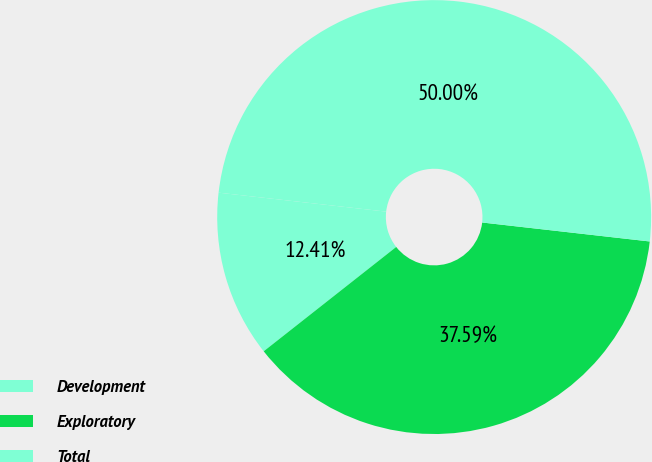Convert chart to OTSL. <chart><loc_0><loc_0><loc_500><loc_500><pie_chart><fcel>Development<fcel>Exploratory<fcel>Total<nl><fcel>12.41%<fcel>37.59%<fcel>50.0%<nl></chart> 